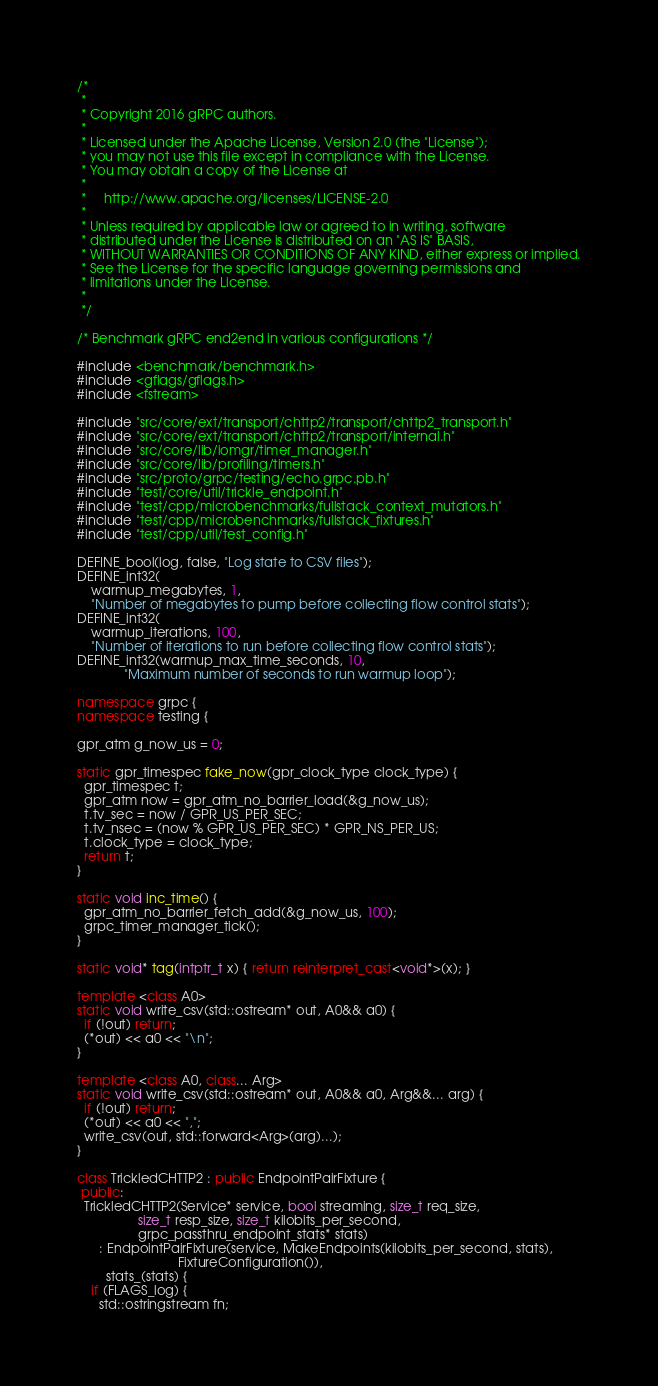Convert code to text. <code><loc_0><loc_0><loc_500><loc_500><_C++_>/*
 *
 * Copyright 2016 gRPC authors.
 *
 * Licensed under the Apache License, Version 2.0 (the "License");
 * you may not use this file except in compliance with the License.
 * You may obtain a copy of the License at
 *
 *     http://www.apache.org/licenses/LICENSE-2.0
 *
 * Unless required by applicable law or agreed to in writing, software
 * distributed under the License is distributed on an "AS IS" BASIS,
 * WITHOUT WARRANTIES OR CONDITIONS OF ANY KIND, either express or implied.
 * See the License for the specific language governing permissions and
 * limitations under the License.
 *
 */

/* Benchmark gRPC end2end in various configurations */

#include <benchmark/benchmark.h>
#include <gflags/gflags.h>
#include <fstream>

#include "src/core/ext/transport/chttp2/transport/chttp2_transport.h"
#include "src/core/ext/transport/chttp2/transport/internal.h"
#include "src/core/lib/iomgr/timer_manager.h"
#include "src/core/lib/profiling/timers.h"
#include "src/proto/grpc/testing/echo.grpc.pb.h"
#include "test/core/util/trickle_endpoint.h"
#include "test/cpp/microbenchmarks/fullstack_context_mutators.h"
#include "test/cpp/microbenchmarks/fullstack_fixtures.h"
#include "test/cpp/util/test_config.h"

DEFINE_bool(log, false, "Log state to CSV files");
DEFINE_int32(
    warmup_megabytes, 1,
    "Number of megabytes to pump before collecting flow control stats");
DEFINE_int32(
    warmup_iterations, 100,
    "Number of iterations to run before collecting flow control stats");
DEFINE_int32(warmup_max_time_seconds, 10,
             "Maximum number of seconds to run warmup loop");

namespace grpc {
namespace testing {

gpr_atm g_now_us = 0;

static gpr_timespec fake_now(gpr_clock_type clock_type) {
  gpr_timespec t;
  gpr_atm now = gpr_atm_no_barrier_load(&g_now_us);
  t.tv_sec = now / GPR_US_PER_SEC;
  t.tv_nsec = (now % GPR_US_PER_SEC) * GPR_NS_PER_US;
  t.clock_type = clock_type;
  return t;
}

static void inc_time() {
  gpr_atm_no_barrier_fetch_add(&g_now_us, 100);
  grpc_timer_manager_tick();
}

static void* tag(intptr_t x) { return reinterpret_cast<void*>(x); }

template <class A0>
static void write_csv(std::ostream* out, A0&& a0) {
  if (!out) return;
  (*out) << a0 << "\n";
}

template <class A0, class... Arg>
static void write_csv(std::ostream* out, A0&& a0, Arg&&... arg) {
  if (!out) return;
  (*out) << a0 << ",";
  write_csv(out, std::forward<Arg>(arg)...);
}

class TrickledCHTTP2 : public EndpointPairFixture {
 public:
  TrickledCHTTP2(Service* service, bool streaming, size_t req_size,
                 size_t resp_size, size_t kilobits_per_second,
                 grpc_passthru_endpoint_stats* stats)
      : EndpointPairFixture(service, MakeEndpoints(kilobits_per_second, stats),
                            FixtureConfiguration()),
        stats_(stats) {
    if (FLAGS_log) {
      std::ostringstream fn;</code> 